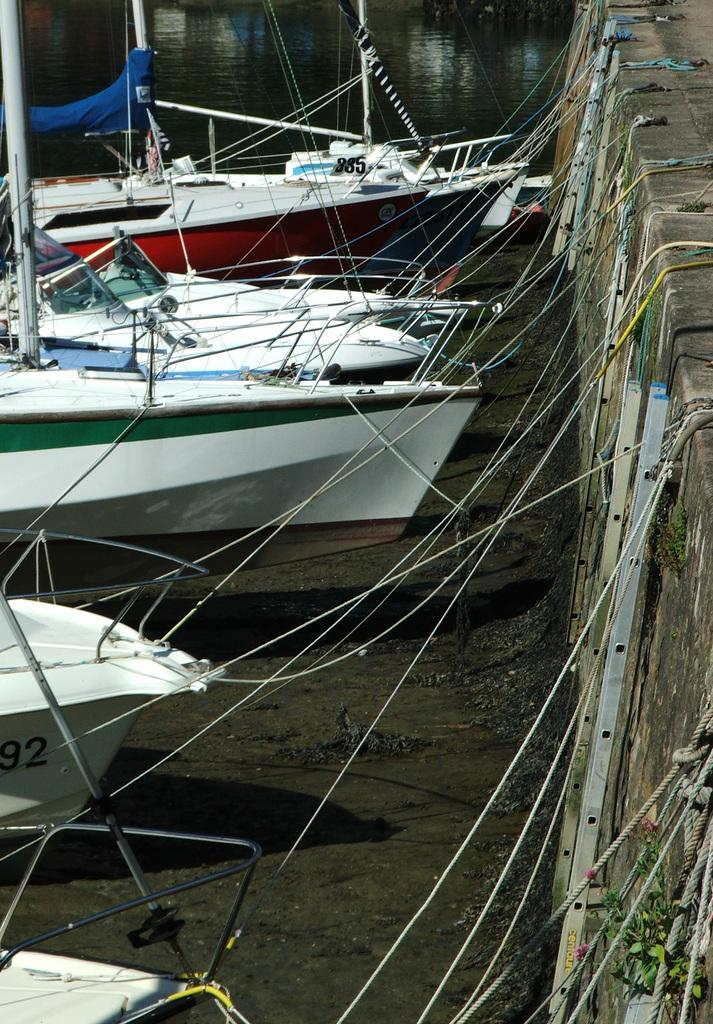What is the main element in the image? There is water in the image. What is floating on the water? There are boats in the water. What is located on the right side of the image? There is a wall on the right side of the image. What are the boats connected to in the image? Ropes are visible in the image, connecting the boats to something else. How many ducks are standing on the feet of the person in the image? There are no ducks or people present in the image. What type of shock can be seen in the image? There is no shock present in the image. 